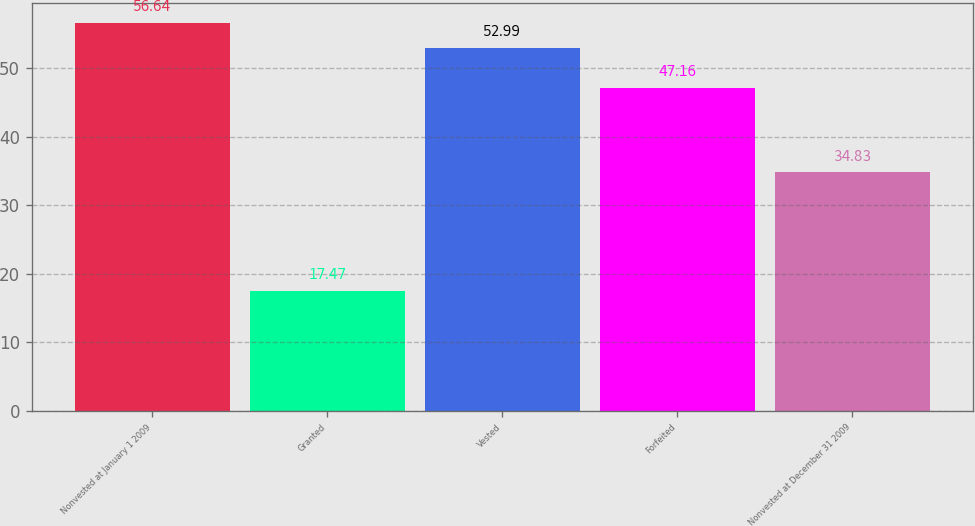Convert chart. <chart><loc_0><loc_0><loc_500><loc_500><bar_chart><fcel>Nonvested at January 1 2009<fcel>Granted<fcel>Vested<fcel>Forfeited<fcel>Nonvested at December 31 2009<nl><fcel>56.64<fcel>17.47<fcel>52.99<fcel>47.16<fcel>34.83<nl></chart> 